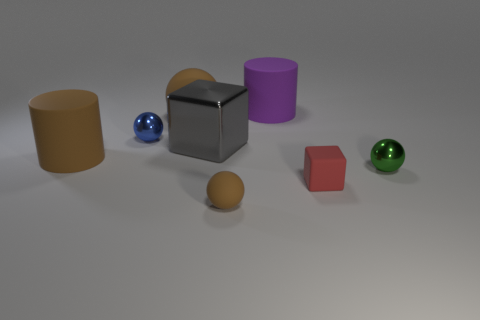Does the brown sphere on the left side of the small brown rubber object have the same material as the brown object that is in front of the red matte block?
Provide a short and direct response. Yes. The tiny object that is the same color as the large sphere is what shape?
Your response must be concise. Sphere. What number of cylinders are made of the same material as the small red thing?
Make the answer very short. 2. What is the color of the small rubber ball?
Your answer should be compact. Brown. Does the large brown object that is in front of the gray shiny cube have the same shape as the matte thing that is behind the big sphere?
Keep it short and to the point. Yes. There is a matte ball in front of the red block; what is its color?
Your response must be concise. Brown. Are there fewer brown matte cylinders that are on the left side of the big sphere than small spheres in front of the big metal cube?
Ensure brevity in your answer.  Yes. How many other things are there of the same material as the red object?
Give a very brief answer. 4. Is the material of the small green thing the same as the brown cylinder?
Your answer should be very brief. No. What number of other objects are the same size as the brown cylinder?
Your answer should be very brief. 3. 